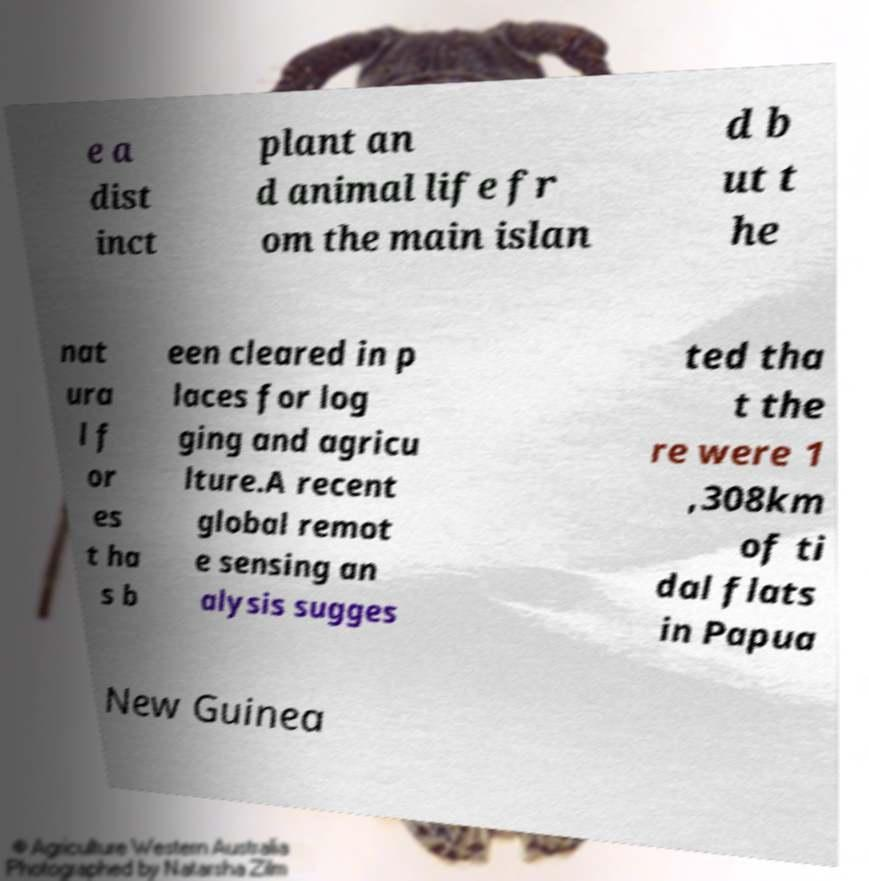What messages or text are displayed in this image? I need them in a readable, typed format. e a dist inct plant an d animal life fr om the main islan d b ut t he nat ura l f or es t ha s b een cleared in p laces for log ging and agricu lture.A recent global remot e sensing an alysis sugges ted tha t the re were 1 ,308km of ti dal flats in Papua New Guinea 